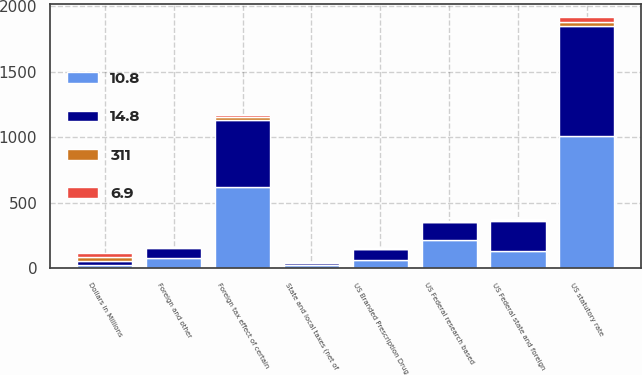Convert chart to OTSL. <chart><loc_0><loc_0><loc_500><loc_500><stacked_bar_chart><ecel><fcel>Dollars in Millions<fcel>US statutory rate<fcel>Foreign tax effect of certain<fcel>US Federal state and foreign<fcel>US Federal research based<fcel>US Branded Prescription Drug<fcel>State and local taxes (net of<fcel>Foreign and other<nl><fcel>14.8<fcel>30<fcel>833<fcel>509<fcel>228<fcel>131<fcel>84<fcel>20<fcel>74<nl><fcel>311<fcel>30<fcel>35<fcel>21.4<fcel>9.6<fcel>5.4<fcel>3.5<fcel>0.8<fcel>3.1<nl><fcel>10.8<fcel>30<fcel>1012<fcel>620<fcel>134<fcel>220<fcel>63<fcel>25<fcel>83<nl><fcel>6.9<fcel>30<fcel>35<fcel>21.4<fcel>4.6<fcel>7.6<fcel>2.2<fcel>0.9<fcel>2.9<nl></chart> 